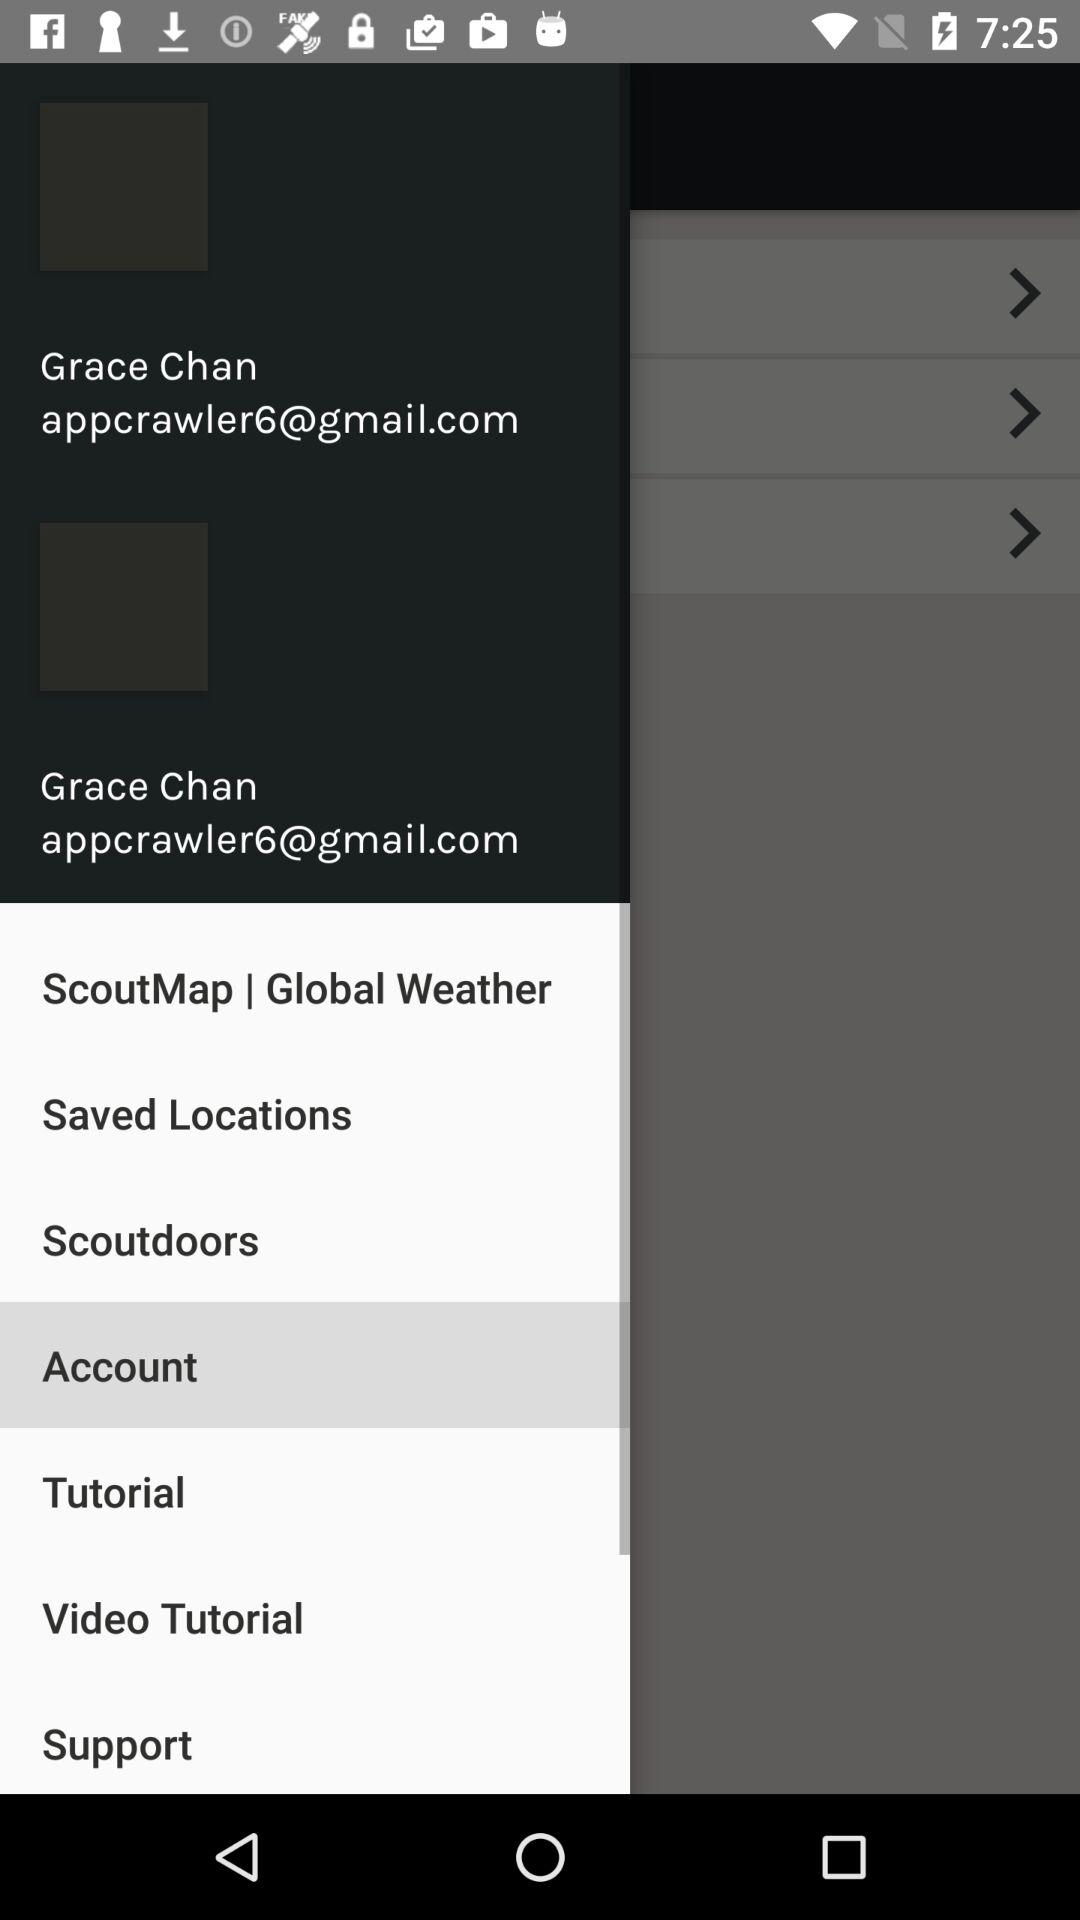What is the name of the user? The name of the user is Grace Chan. 